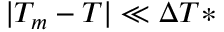<formula> <loc_0><loc_0><loc_500><loc_500>| T _ { m } - T | \ll \Delta T *</formula> 